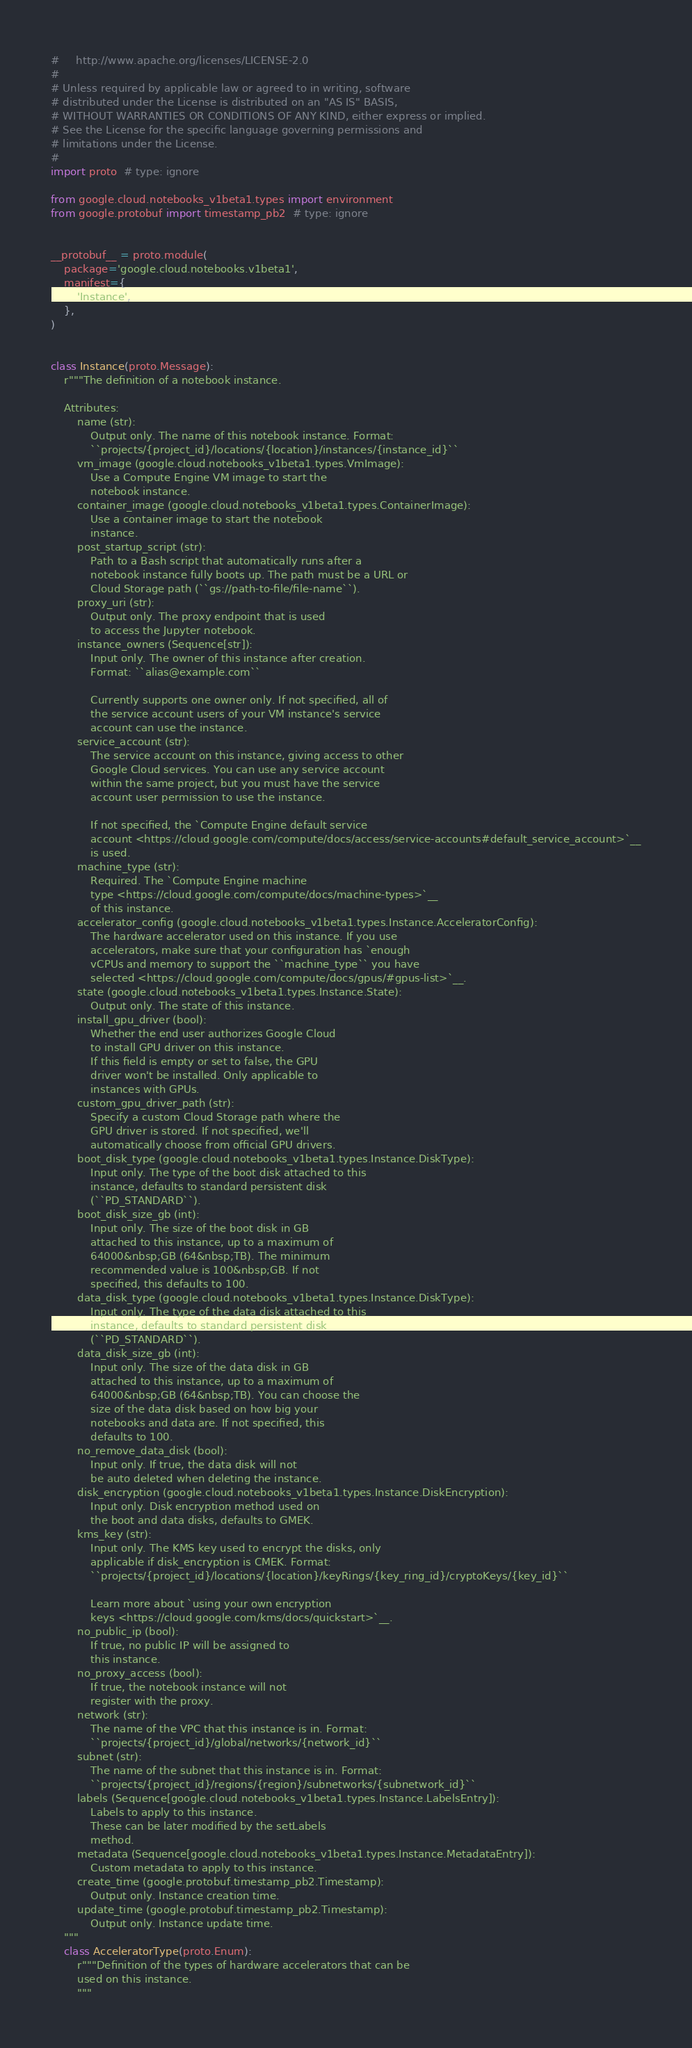Convert code to text. <code><loc_0><loc_0><loc_500><loc_500><_Python_>#     http://www.apache.org/licenses/LICENSE-2.0
#
# Unless required by applicable law or agreed to in writing, software
# distributed under the License is distributed on an "AS IS" BASIS,
# WITHOUT WARRANTIES OR CONDITIONS OF ANY KIND, either express or implied.
# See the License for the specific language governing permissions and
# limitations under the License.
#
import proto  # type: ignore

from google.cloud.notebooks_v1beta1.types import environment
from google.protobuf import timestamp_pb2  # type: ignore


__protobuf__ = proto.module(
    package='google.cloud.notebooks.v1beta1',
    manifest={
        'Instance',
    },
)


class Instance(proto.Message):
    r"""The definition of a notebook instance.

    Attributes:
        name (str):
            Output only. The name of this notebook instance. Format:
            ``projects/{project_id}/locations/{location}/instances/{instance_id}``
        vm_image (google.cloud.notebooks_v1beta1.types.VmImage):
            Use a Compute Engine VM image to start the
            notebook instance.
        container_image (google.cloud.notebooks_v1beta1.types.ContainerImage):
            Use a container image to start the notebook
            instance.
        post_startup_script (str):
            Path to a Bash script that automatically runs after a
            notebook instance fully boots up. The path must be a URL or
            Cloud Storage path (``gs://path-to-file/file-name``).
        proxy_uri (str):
            Output only. The proxy endpoint that is used
            to access the Jupyter notebook.
        instance_owners (Sequence[str]):
            Input only. The owner of this instance after creation.
            Format: ``alias@example.com``

            Currently supports one owner only. If not specified, all of
            the service account users of your VM instance's service
            account can use the instance.
        service_account (str):
            The service account on this instance, giving access to other
            Google Cloud services. You can use any service account
            within the same project, but you must have the service
            account user permission to use the instance.

            If not specified, the `Compute Engine default service
            account <https://cloud.google.com/compute/docs/access/service-accounts#default_service_account>`__
            is used.
        machine_type (str):
            Required. The `Compute Engine machine
            type <https://cloud.google.com/compute/docs/machine-types>`__
            of this instance.
        accelerator_config (google.cloud.notebooks_v1beta1.types.Instance.AcceleratorConfig):
            The hardware accelerator used on this instance. If you use
            accelerators, make sure that your configuration has `enough
            vCPUs and memory to support the ``machine_type`` you have
            selected <https://cloud.google.com/compute/docs/gpus/#gpus-list>`__.
        state (google.cloud.notebooks_v1beta1.types.Instance.State):
            Output only. The state of this instance.
        install_gpu_driver (bool):
            Whether the end user authorizes Google Cloud
            to install GPU driver on this instance.
            If this field is empty or set to false, the GPU
            driver won't be installed. Only applicable to
            instances with GPUs.
        custom_gpu_driver_path (str):
            Specify a custom Cloud Storage path where the
            GPU driver is stored. If not specified, we'll
            automatically choose from official GPU drivers.
        boot_disk_type (google.cloud.notebooks_v1beta1.types.Instance.DiskType):
            Input only. The type of the boot disk attached to this
            instance, defaults to standard persistent disk
            (``PD_STANDARD``).
        boot_disk_size_gb (int):
            Input only. The size of the boot disk in GB
            attached to this instance, up to a maximum of
            64000&nbsp;GB (64&nbsp;TB). The minimum
            recommended value is 100&nbsp;GB. If not
            specified, this defaults to 100.
        data_disk_type (google.cloud.notebooks_v1beta1.types.Instance.DiskType):
            Input only. The type of the data disk attached to this
            instance, defaults to standard persistent disk
            (``PD_STANDARD``).
        data_disk_size_gb (int):
            Input only. The size of the data disk in GB
            attached to this instance, up to a maximum of
            64000&nbsp;GB (64&nbsp;TB). You can choose the
            size of the data disk based on how big your
            notebooks and data are. If not specified, this
            defaults to 100.
        no_remove_data_disk (bool):
            Input only. If true, the data disk will not
            be auto deleted when deleting the instance.
        disk_encryption (google.cloud.notebooks_v1beta1.types.Instance.DiskEncryption):
            Input only. Disk encryption method used on
            the boot and data disks, defaults to GMEK.
        kms_key (str):
            Input only. The KMS key used to encrypt the disks, only
            applicable if disk_encryption is CMEK. Format:
            ``projects/{project_id}/locations/{location}/keyRings/{key_ring_id}/cryptoKeys/{key_id}``

            Learn more about `using your own encryption
            keys <https://cloud.google.com/kms/docs/quickstart>`__.
        no_public_ip (bool):
            If true, no public IP will be assigned to
            this instance.
        no_proxy_access (bool):
            If true, the notebook instance will not
            register with the proxy.
        network (str):
            The name of the VPC that this instance is in. Format:
            ``projects/{project_id}/global/networks/{network_id}``
        subnet (str):
            The name of the subnet that this instance is in. Format:
            ``projects/{project_id}/regions/{region}/subnetworks/{subnetwork_id}``
        labels (Sequence[google.cloud.notebooks_v1beta1.types.Instance.LabelsEntry]):
            Labels to apply to this instance.
            These can be later modified by the setLabels
            method.
        metadata (Sequence[google.cloud.notebooks_v1beta1.types.Instance.MetadataEntry]):
            Custom metadata to apply to this instance.
        create_time (google.protobuf.timestamp_pb2.Timestamp):
            Output only. Instance creation time.
        update_time (google.protobuf.timestamp_pb2.Timestamp):
            Output only. Instance update time.
    """
    class AcceleratorType(proto.Enum):
        r"""Definition of the types of hardware accelerators that can be
        used on this instance.
        """</code> 